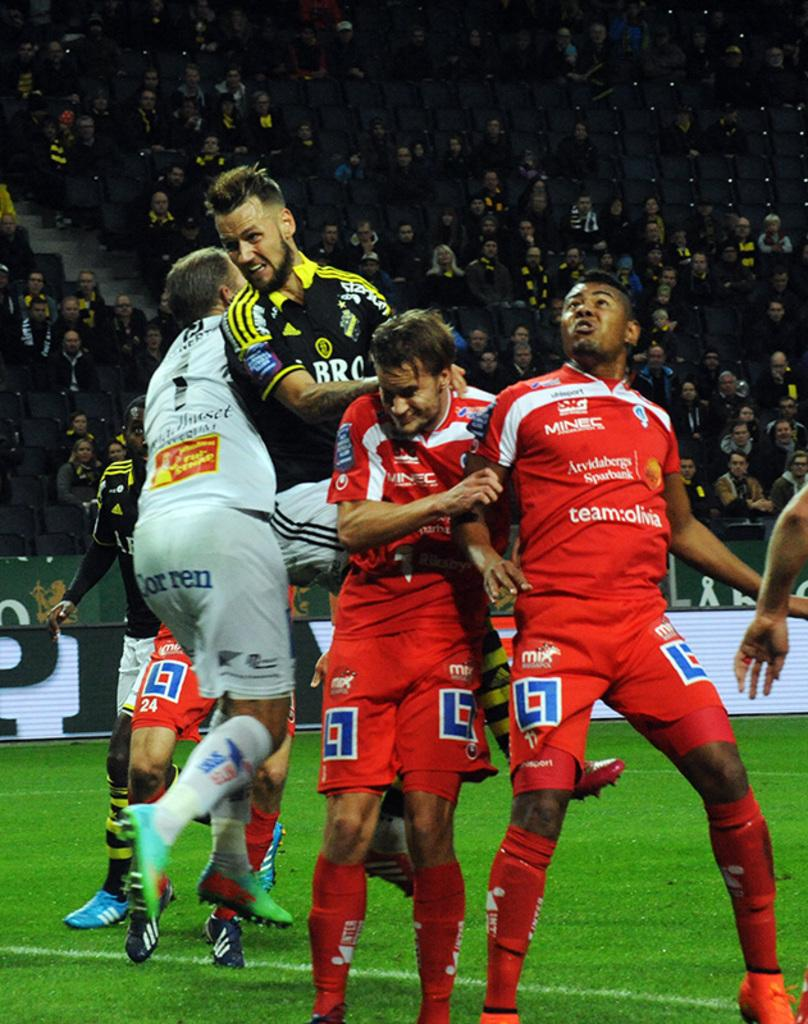<image>
Relay a brief, clear account of the picture shown. a group of soccer players, opne with shorts that say mix on them 